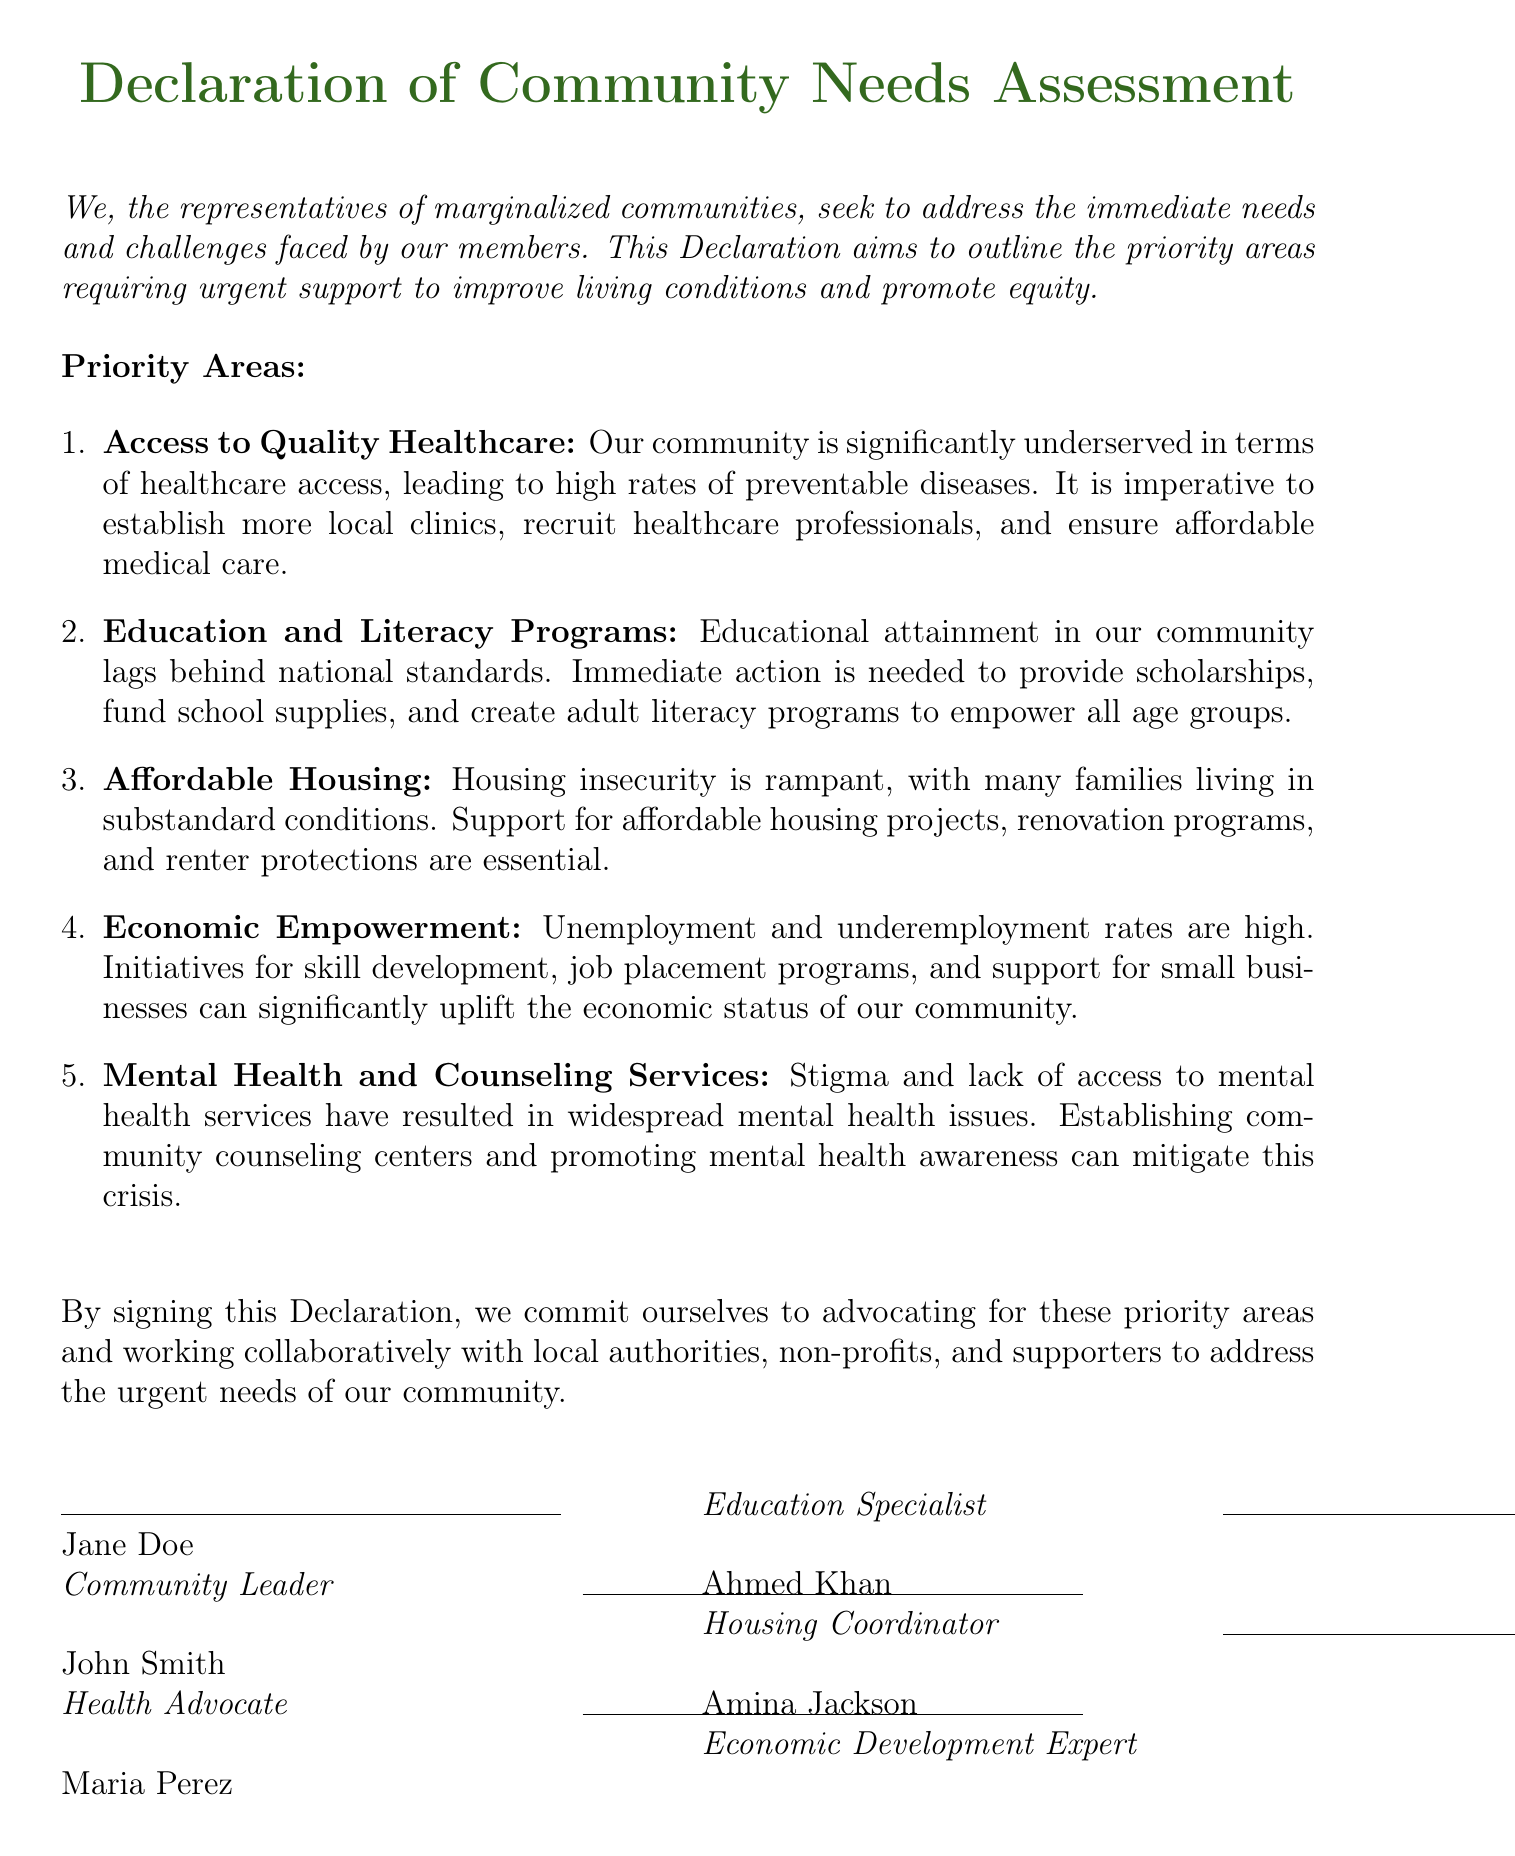What is the title of the document? The title of the document is the main heading that identifies its purpose and content.
Answer: Declaration of Community Needs Assessment How many priority areas are identified? The document lists the number of priority areas that require urgent support for the community.
Answer: Five What is the first priority area mentioned? The first item in the list outlines the area that needs urgent attention regarding healthcare access.
Answer: Access to Quality Healthcare Who is the community leader that signed the declaration? The name of the individual representing the community as a leader is mentioned at the end of the document.
Answer: Jane Doe What issue is addressed under the priority area of Education? The document describes the need for initiatives related to educational attainment in the community.
Answer: Scholarships What specific health services are needed according to the priority areas? The declaration highlights the type of health services that are limited and need expansion for community welfare.
Answer: Local clinics What type of program is suggested for economic empowerment? The document specifies a particular type of initiative aimed at improving the economic situation of the community.
Answer: Job placement programs Which signature corresponds to the Housing Coordinator? The role of each signer is listed, identifying their specific area of focus or expertise in the community.
Answer: Ahmed Khan 